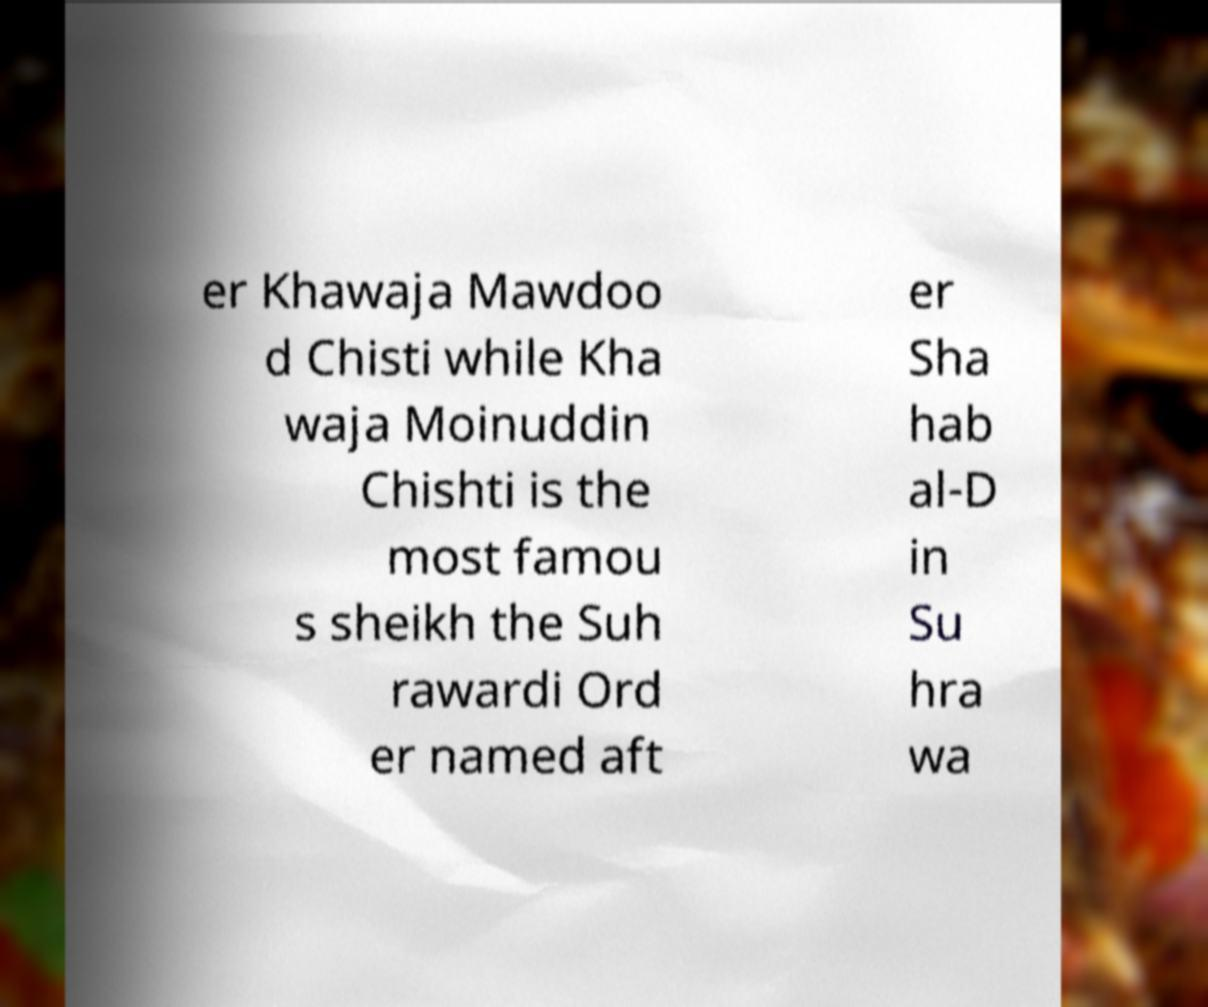Can you read and provide the text displayed in the image?This photo seems to have some interesting text. Can you extract and type it out for me? er Khawaja Mawdoo d Chisti while Kha waja Moinuddin Chishti is the most famou s sheikh the Suh rawardi Ord er named aft er Sha hab al-D in Su hra wa 